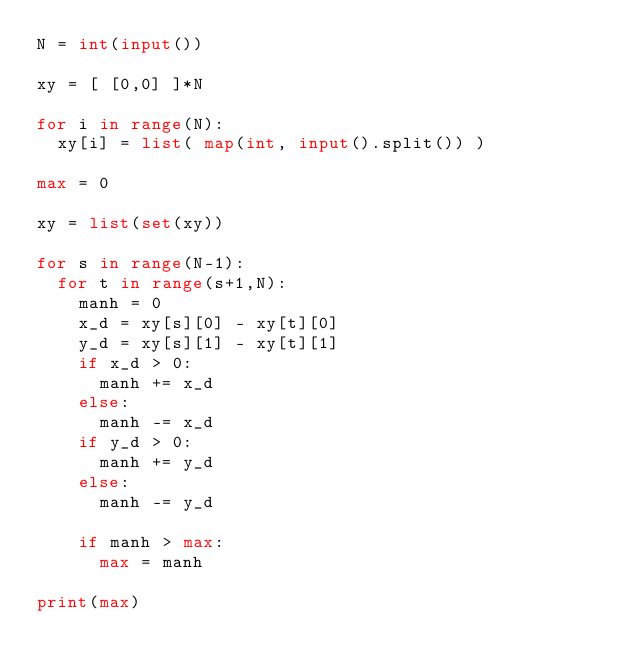Convert code to text. <code><loc_0><loc_0><loc_500><loc_500><_Python_>N = int(input())

xy = [ [0,0] ]*N

for i in range(N):
  xy[i] = list( map(int, input().split()) )

max = 0

xy = list(set(xy))

for s in range(N-1):
  for t in range(s+1,N):
    manh = 0
    x_d = xy[s][0] - xy[t][0]
    y_d = xy[s][1] - xy[t][1]
    if x_d > 0:
      manh += x_d
    else:
      manh -= x_d
    if y_d > 0:
      manh += y_d
    else:
      manh -= y_d
    
    if manh > max:
      max = manh

print(max)</code> 